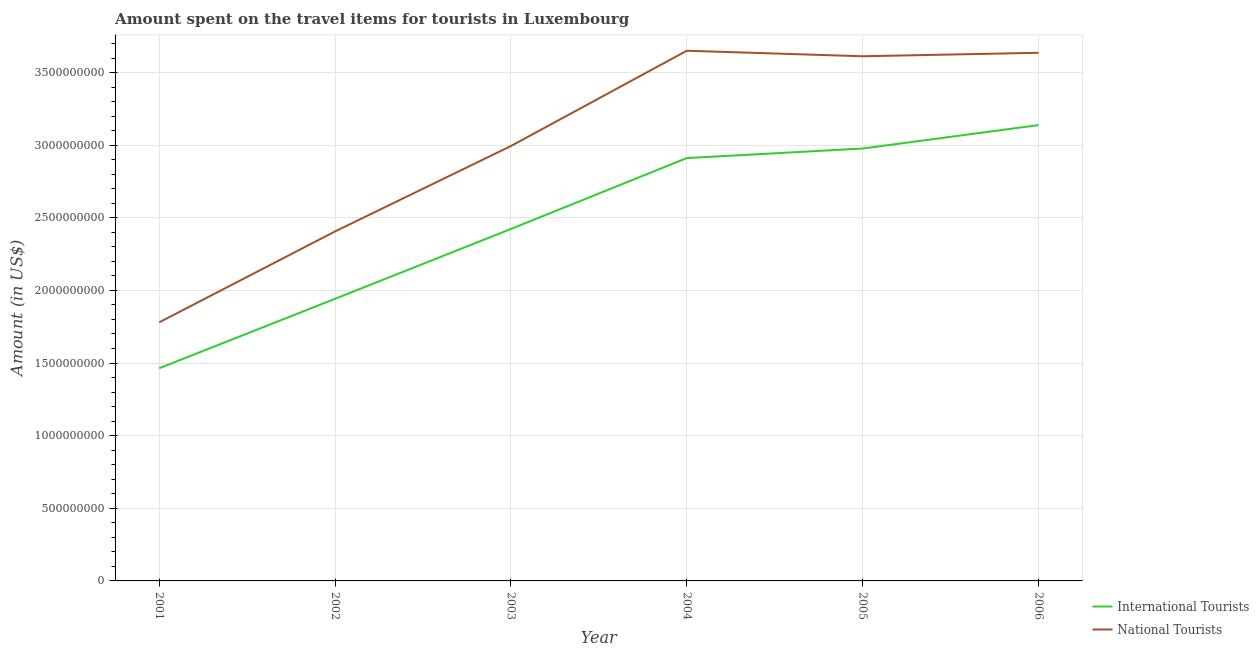How many different coloured lines are there?
Make the answer very short. 2. Does the line corresponding to amount spent on travel items of international tourists intersect with the line corresponding to amount spent on travel items of national tourists?
Give a very brief answer. No. Is the number of lines equal to the number of legend labels?
Your answer should be compact. Yes. What is the amount spent on travel items of international tourists in 2006?
Your answer should be compact. 3.14e+09. Across all years, what is the maximum amount spent on travel items of international tourists?
Offer a terse response. 3.14e+09. Across all years, what is the minimum amount spent on travel items of national tourists?
Keep it short and to the point. 1.78e+09. In which year was the amount spent on travel items of national tourists maximum?
Keep it short and to the point. 2004. In which year was the amount spent on travel items of national tourists minimum?
Give a very brief answer. 2001. What is the total amount spent on travel items of national tourists in the graph?
Give a very brief answer. 1.81e+1. What is the difference between the amount spent on travel items of national tourists in 2002 and that in 2004?
Make the answer very short. -1.24e+09. What is the difference between the amount spent on travel items of national tourists in 2002 and the amount spent on travel items of international tourists in 2006?
Ensure brevity in your answer.  -7.32e+08. What is the average amount spent on travel items of national tourists per year?
Make the answer very short. 3.01e+09. In the year 2002, what is the difference between the amount spent on travel items of international tourists and amount spent on travel items of national tourists?
Ensure brevity in your answer.  -4.64e+08. What is the ratio of the amount spent on travel items of national tourists in 2005 to that in 2006?
Offer a very short reply. 0.99. Is the amount spent on travel items of national tourists in 2001 less than that in 2005?
Provide a short and direct response. Yes. What is the difference between the highest and the second highest amount spent on travel items of national tourists?
Offer a terse response. 1.40e+07. What is the difference between the highest and the lowest amount spent on travel items of national tourists?
Provide a short and direct response. 1.87e+09. Is the sum of the amount spent on travel items of national tourists in 2001 and 2006 greater than the maximum amount spent on travel items of international tourists across all years?
Offer a very short reply. Yes. Does the amount spent on travel items of international tourists monotonically increase over the years?
Ensure brevity in your answer.  Yes. Is the amount spent on travel items of national tourists strictly less than the amount spent on travel items of international tourists over the years?
Ensure brevity in your answer.  No. How many lines are there?
Keep it short and to the point. 2. How many years are there in the graph?
Give a very brief answer. 6. What is the difference between two consecutive major ticks on the Y-axis?
Provide a succinct answer. 5.00e+08. Are the values on the major ticks of Y-axis written in scientific E-notation?
Your answer should be compact. No. Does the graph contain any zero values?
Keep it short and to the point. No. How many legend labels are there?
Ensure brevity in your answer.  2. What is the title of the graph?
Give a very brief answer. Amount spent on the travel items for tourists in Luxembourg. Does "Canada" appear as one of the legend labels in the graph?
Offer a very short reply. No. What is the label or title of the Y-axis?
Your answer should be compact. Amount (in US$). What is the Amount (in US$) of International Tourists in 2001?
Give a very brief answer. 1.46e+09. What is the Amount (in US$) in National Tourists in 2001?
Make the answer very short. 1.78e+09. What is the Amount (in US$) in International Tourists in 2002?
Provide a succinct answer. 1.94e+09. What is the Amount (in US$) of National Tourists in 2002?
Offer a terse response. 2.41e+09. What is the Amount (in US$) in International Tourists in 2003?
Provide a succinct answer. 2.42e+09. What is the Amount (in US$) of National Tourists in 2003?
Keep it short and to the point. 2.99e+09. What is the Amount (in US$) in International Tourists in 2004?
Your answer should be compact. 2.91e+09. What is the Amount (in US$) in National Tourists in 2004?
Make the answer very short. 3.65e+09. What is the Amount (in US$) of International Tourists in 2005?
Your answer should be very brief. 2.98e+09. What is the Amount (in US$) in National Tourists in 2005?
Give a very brief answer. 3.61e+09. What is the Amount (in US$) in International Tourists in 2006?
Make the answer very short. 3.14e+09. What is the Amount (in US$) in National Tourists in 2006?
Give a very brief answer. 3.64e+09. Across all years, what is the maximum Amount (in US$) of International Tourists?
Your response must be concise. 3.14e+09. Across all years, what is the maximum Amount (in US$) of National Tourists?
Make the answer very short. 3.65e+09. Across all years, what is the minimum Amount (in US$) of International Tourists?
Provide a succinct answer. 1.46e+09. Across all years, what is the minimum Amount (in US$) in National Tourists?
Offer a terse response. 1.78e+09. What is the total Amount (in US$) of International Tourists in the graph?
Offer a very short reply. 1.49e+1. What is the total Amount (in US$) in National Tourists in the graph?
Ensure brevity in your answer.  1.81e+1. What is the difference between the Amount (in US$) of International Tourists in 2001 and that in 2002?
Your response must be concise. -4.78e+08. What is the difference between the Amount (in US$) of National Tourists in 2001 and that in 2002?
Provide a short and direct response. -6.26e+08. What is the difference between the Amount (in US$) in International Tourists in 2001 and that in 2003?
Provide a succinct answer. -9.59e+08. What is the difference between the Amount (in US$) of National Tourists in 2001 and that in 2003?
Give a very brief answer. -1.21e+09. What is the difference between the Amount (in US$) in International Tourists in 2001 and that in 2004?
Your answer should be compact. -1.45e+09. What is the difference between the Amount (in US$) in National Tourists in 2001 and that in 2004?
Your answer should be very brief. -1.87e+09. What is the difference between the Amount (in US$) of International Tourists in 2001 and that in 2005?
Offer a terse response. -1.51e+09. What is the difference between the Amount (in US$) in National Tourists in 2001 and that in 2005?
Your answer should be very brief. -1.83e+09. What is the difference between the Amount (in US$) in International Tourists in 2001 and that in 2006?
Give a very brief answer. -1.67e+09. What is the difference between the Amount (in US$) of National Tourists in 2001 and that in 2006?
Provide a succinct answer. -1.86e+09. What is the difference between the Amount (in US$) of International Tourists in 2002 and that in 2003?
Make the answer very short. -4.81e+08. What is the difference between the Amount (in US$) in National Tourists in 2002 and that in 2003?
Offer a terse response. -5.88e+08. What is the difference between the Amount (in US$) of International Tourists in 2002 and that in 2004?
Your response must be concise. -9.69e+08. What is the difference between the Amount (in US$) of National Tourists in 2002 and that in 2004?
Provide a succinct answer. -1.24e+09. What is the difference between the Amount (in US$) of International Tourists in 2002 and that in 2005?
Offer a terse response. -1.04e+09. What is the difference between the Amount (in US$) in National Tourists in 2002 and that in 2005?
Your answer should be very brief. -1.21e+09. What is the difference between the Amount (in US$) of International Tourists in 2002 and that in 2006?
Your response must be concise. -1.20e+09. What is the difference between the Amount (in US$) of National Tourists in 2002 and that in 2006?
Your response must be concise. -1.23e+09. What is the difference between the Amount (in US$) in International Tourists in 2003 and that in 2004?
Offer a very short reply. -4.88e+08. What is the difference between the Amount (in US$) of National Tourists in 2003 and that in 2004?
Ensure brevity in your answer.  -6.56e+08. What is the difference between the Amount (in US$) in International Tourists in 2003 and that in 2005?
Keep it short and to the point. -5.54e+08. What is the difference between the Amount (in US$) of National Tourists in 2003 and that in 2005?
Your answer should be very brief. -6.18e+08. What is the difference between the Amount (in US$) in International Tourists in 2003 and that in 2006?
Offer a terse response. -7.15e+08. What is the difference between the Amount (in US$) in National Tourists in 2003 and that in 2006?
Provide a succinct answer. -6.42e+08. What is the difference between the Amount (in US$) of International Tourists in 2004 and that in 2005?
Make the answer very short. -6.60e+07. What is the difference between the Amount (in US$) in National Tourists in 2004 and that in 2005?
Your answer should be compact. 3.80e+07. What is the difference between the Amount (in US$) in International Tourists in 2004 and that in 2006?
Your response must be concise. -2.27e+08. What is the difference between the Amount (in US$) of National Tourists in 2004 and that in 2006?
Give a very brief answer. 1.40e+07. What is the difference between the Amount (in US$) of International Tourists in 2005 and that in 2006?
Your response must be concise. -1.61e+08. What is the difference between the Amount (in US$) in National Tourists in 2005 and that in 2006?
Offer a terse response. -2.40e+07. What is the difference between the Amount (in US$) of International Tourists in 2001 and the Amount (in US$) of National Tourists in 2002?
Ensure brevity in your answer.  -9.42e+08. What is the difference between the Amount (in US$) in International Tourists in 2001 and the Amount (in US$) in National Tourists in 2003?
Provide a succinct answer. -1.53e+09. What is the difference between the Amount (in US$) of International Tourists in 2001 and the Amount (in US$) of National Tourists in 2004?
Provide a succinct answer. -2.19e+09. What is the difference between the Amount (in US$) in International Tourists in 2001 and the Amount (in US$) in National Tourists in 2005?
Offer a very short reply. -2.15e+09. What is the difference between the Amount (in US$) of International Tourists in 2001 and the Amount (in US$) of National Tourists in 2006?
Your answer should be compact. -2.17e+09. What is the difference between the Amount (in US$) of International Tourists in 2002 and the Amount (in US$) of National Tourists in 2003?
Provide a succinct answer. -1.05e+09. What is the difference between the Amount (in US$) in International Tourists in 2002 and the Amount (in US$) in National Tourists in 2004?
Make the answer very short. -1.71e+09. What is the difference between the Amount (in US$) in International Tourists in 2002 and the Amount (in US$) in National Tourists in 2005?
Your response must be concise. -1.67e+09. What is the difference between the Amount (in US$) in International Tourists in 2002 and the Amount (in US$) in National Tourists in 2006?
Your response must be concise. -1.69e+09. What is the difference between the Amount (in US$) of International Tourists in 2003 and the Amount (in US$) of National Tourists in 2004?
Offer a terse response. -1.23e+09. What is the difference between the Amount (in US$) of International Tourists in 2003 and the Amount (in US$) of National Tourists in 2005?
Your answer should be compact. -1.19e+09. What is the difference between the Amount (in US$) in International Tourists in 2003 and the Amount (in US$) in National Tourists in 2006?
Give a very brief answer. -1.21e+09. What is the difference between the Amount (in US$) of International Tourists in 2004 and the Amount (in US$) of National Tourists in 2005?
Make the answer very short. -7.01e+08. What is the difference between the Amount (in US$) in International Tourists in 2004 and the Amount (in US$) in National Tourists in 2006?
Your answer should be very brief. -7.25e+08. What is the difference between the Amount (in US$) of International Tourists in 2005 and the Amount (in US$) of National Tourists in 2006?
Give a very brief answer. -6.59e+08. What is the average Amount (in US$) of International Tourists per year?
Offer a very short reply. 2.48e+09. What is the average Amount (in US$) of National Tourists per year?
Your response must be concise. 3.01e+09. In the year 2001, what is the difference between the Amount (in US$) of International Tourists and Amount (in US$) of National Tourists?
Your answer should be compact. -3.16e+08. In the year 2002, what is the difference between the Amount (in US$) in International Tourists and Amount (in US$) in National Tourists?
Keep it short and to the point. -4.64e+08. In the year 2003, what is the difference between the Amount (in US$) of International Tourists and Amount (in US$) of National Tourists?
Your response must be concise. -5.71e+08. In the year 2004, what is the difference between the Amount (in US$) in International Tourists and Amount (in US$) in National Tourists?
Make the answer very short. -7.39e+08. In the year 2005, what is the difference between the Amount (in US$) in International Tourists and Amount (in US$) in National Tourists?
Your answer should be very brief. -6.35e+08. In the year 2006, what is the difference between the Amount (in US$) of International Tourists and Amount (in US$) of National Tourists?
Your answer should be compact. -4.98e+08. What is the ratio of the Amount (in US$) in International Tourists in 2001 to that in 2002?
Your answer should be very brief. 0.75. What is the ratio of the Amount (in US$) in National Tourists in 2001 to that in 2002?
Provide a short and direct response. 0.74. What is the ratio of the Amount (in US$) of International Tourists in 2001 to that in 2003?
Give a very brief answer. 0.6. What is the ratio of the Amount (in US$) of National Tourists in 2001 to that in 2003?
Ensure brevity in your answer.  0.59. What is the ratio of the Amount (in US$) in International Tourists in 2001 to that in 2004?
Provide a short and direct response. 0.5. What is the ratio of the Amount (in US$) in National Tourists in 2001 to that in 2004?
Ensure brevity in your answer.  0.49. What is the ratio of the Amount (in US$) of International Tourists in 2001 to that in 2005?
Your response must be concise. 0.49. What is the ratio of the Amount (in US$) of National Tourists in 2001 to that in 2005?
Make the answer very short. 0.49. What is the ratio of the Amount (in US$) of International Tourists in 2001 to that in 2006?
Offer a very short reply. 0.47. What is the ratio of the Amount (in US$) in National Tourists in 2001 to that in 2006?
Your response must be concise. 0.49. What is the ratio of the Amount (in US$) of International Tourists in 2002 to that in 2003?
Ensure brevity in your answer.  0.8. What is the ratio of the Amount (in US$) in National Tourists in 2002 to that in 2003?
Offer a terse response. 0.8. What is the ratio of the Amount (in US$) in International Tourists in 2002 to that in 2004?
Your response must be concise. 0.67. What is the ratio of the Amount (in US$) of National Tourists in 2002 to that in 2004?
Make the answer very short. 0.66. What is the ratio of the Amount (in US$) of International Tourists in 2002 to that in 2005?
Keep it short and to the point. 0.65. What is the ratio of the Amount (in US$) in National Tourists in 2002 to that in 2005?
Make the answer very short. 0.67. What is the ratio of the Amount (in US$) in International Tourists in 2002 to that in 2006?
Provide a succinct answer. 0.62. What is the ratio of the Amount (in US$) in National Tourists in 2002 to that in 2006?
Your response must be concise. 0.66. What is the ratio of the Amount (in US$) of International Tourists in 2003 to that in 2004?
Your answer should be very brief. 0.83. What is the ratio of the Amount (in US$) of National Tourists in 2003 to that in 2004?
Your answer should be compact. 0.82. What is the ratio of the Amount (in US$) in International Tourists in 2003 to that in 2005?
Provide a short and direct response. 0.81. What is the ratio of the Amount (in US$) of National Tourists in 2003 to that in 2005?
Your response must be concise. 0.83. What is the ratio of the Amount (in US$) in International Tourists in 2003 to that in 2006?
Your answer should be very brief. 0.77. What is the ratio of the Amount (in US$) of National Tourists in 2003 to that in 2006?
Provide a succinct answer. 0.82. What is the ratio of the Amount (in US$) of International Tourists in 2004 to that in 2005?
Offer a very short reply. 0.98. What is the ratio of the Amount (in US$) of National Tourists in 2004 to that in 2005?
Offer a terse response. 1.01. What is the ratio of the Amount (in US$) in International Tourists in 2004 to that in 2006?
Offer a very short reply. 0.93. What is the ratio of the Amount (in US$) of National Tourists in 2004 to that in 2006?
Your answer should be very brief. 1. What is the ratio of the Amount (in US$) in International Tourists in 2005 to that in 2006?
Provide a succinct answer. 0.95. What is the ratio of the Amount (in US$) of National Tourists in 2005 to that in 2006?
Offer a very short reply. 0.99. What is the difference between the highest and the second highest Amount (in US$) of International Tourists?
Your answer should be very brief. 1.61e+08. What is the difference between the highest and the second highest Amount (in US$) of National Tourists?
Your answer should be very brief. 1.40e+07. What is the difference between the highest and the lowest Amount (in US$) of International Tourists?
Your response must be concise. 1.67e+09. What is the difference between the highest and the lowest Amount (in US$) in National Tourists?
Make the answer very short. 1.87e+09. 